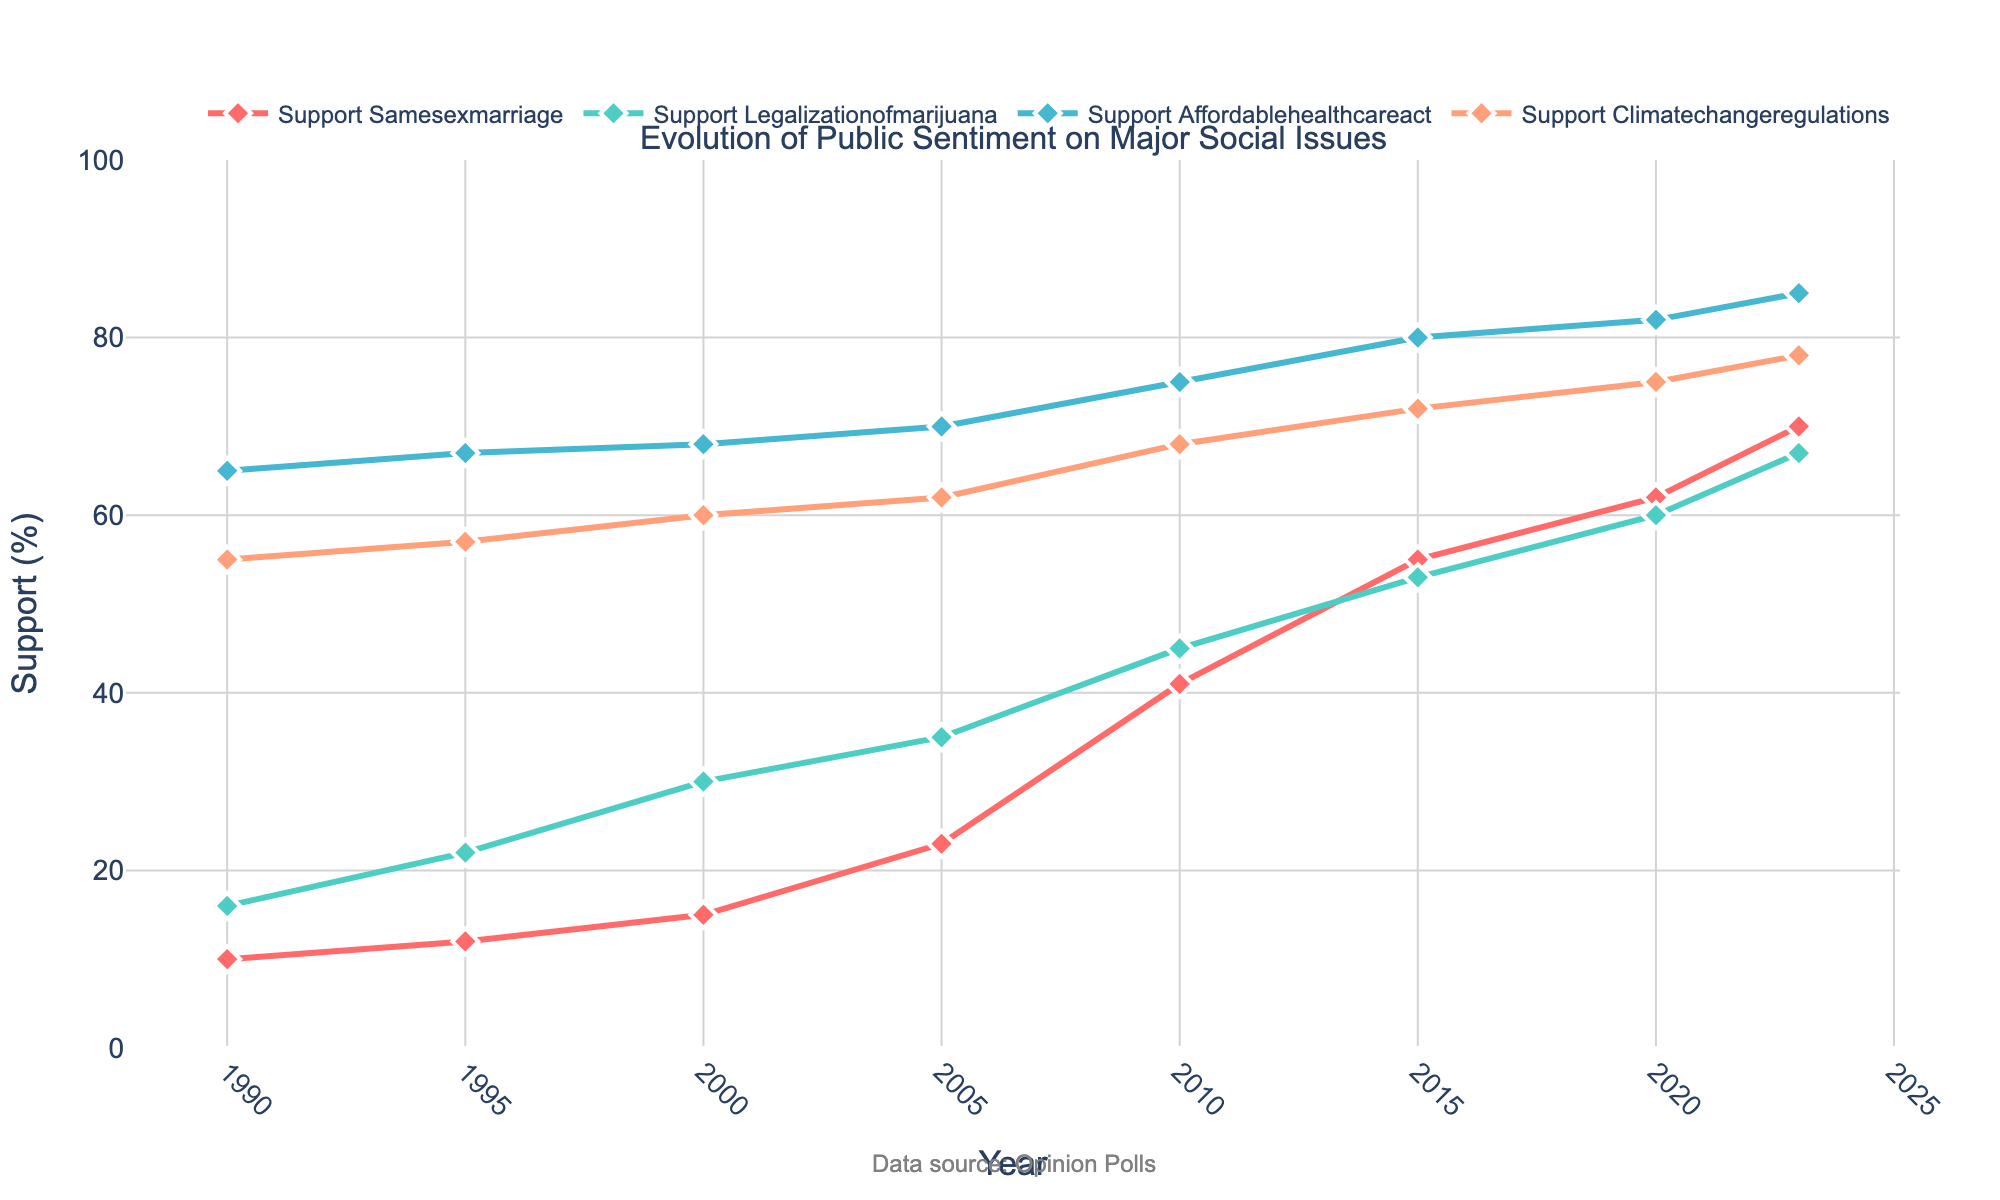What is the title of the plot? The title is displayed at the top of the plot as text, guiding the viewer's attention to the main subject being visualized. In this case, it describes the evolution of public sentiment on major social issues over the past 30 years.
Answer: Evolution of Public Sentiment on Major Social Issues How many years of data are represented in the plot? The x-axis, labeled as "Year," shows data points starting from 1990 and ending in 2023. The years listed are sequentially ordered, giving a clear indication of the time span.
Answer: 34 years What percentage of people supported the legalization of marijuana in 2000? By locating the year 2000 along the x-axis and following it vertically to the data point for "Support Legalization Of Marijuana," we observe the y-axis value.
Answer: 30% By how much has support for same-sex marriage increased from 1990 to 2023? Identify the y-axis values for the years 1990 and 2023 for the "Support SameSex Marriage" line, then calculate the difference between these two percentages.
Answer: 60% Which social issue has the highest level of support in 2023? Compare the data points for 2023 across all four lines representing different social issues, and identify the one with the highest y-axis value.
Answer: Affordable Healthcare Act What is the overall trend for support for climate change regulations from 1990 to 2023? Analyze the line representing "Support Climate Change Regulations" from the start to the end of the timeline, noting the direction of change.
Answer: Increasing Between 2010 and 2020, which issue saw the largest increase in support? Calculate the changes in support for all issues between the years 2010 and 2020, then identify the one with the greatest numerical increase.
Answer: Same-sex marriage How does the public sentiment for the Affordable Healthcare Act in 2010 compare to that in 2023? Compare the y-axis values for the "Support Affordable Healthcare Act" line in the years 2010 and 2023 to determine the change in support.
Answer: Increased What is the average support for the legalization of marijuana from 1990 to 2023? Sum the values of the support for the legalization of marijuana at each data point (1990, 1995, 2000, 2005, 2010, 2015, 2020, 2023), then divide by the number of data points.
Answer: 40.75% Which two social issues had almost the same level of support in any year between 1990 and 2023? Identify any year on the x-axis where the lines representing different social issues have closely overlapping data points, indicating nearly identical levels of support.
Answer: Legalization of marijuana and Affordable Healthcare Act in 2015 